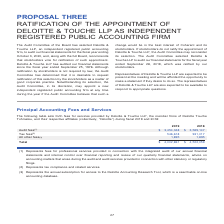According to Coherent's financial document, What do tax fees represent? tax compliance and related services.. The document states: "(2) Represents tax compliance and related services...." Also, What do all other fees represent? the annual subscription for access to the Deloitte Accounting Research Tool, which is a searchable on-line accounting database.. The document states: "(3) Represents the annual subscription for access to the Deloitte Accounting Research Tool, which is a searchable on-line accounting database...." Also, What are the types of principal accounting fees and services? The document contains multiple relevant values: Audit fees, Tax fees, All other fees. From the document: "Audit fees (1) All other fees (3) Tax fees (2)..." Additionally, In which year were tax fees larger? According to the financial document, 2018. The relevant text states: "2019 2018..." Also, can you calculate: What was the change in All other fees in 2019 from 2018? I cannot find a specific answer to this question in the financial document. Also, can you calculate: What was the percentage change in All other fees in 2019 from 2018? I cannot find a specific answer to this question in the financial document. 